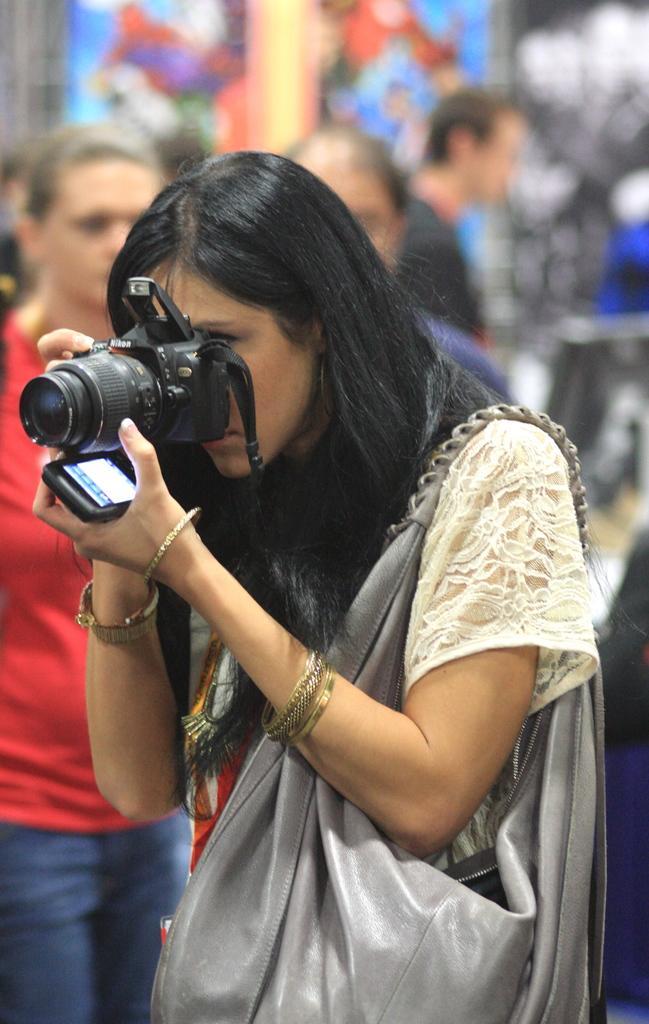How would you summarize this image in a sentence or two? In this image, There is a woman standing and holding a camera and a mobile , In the background there are some people walking. 